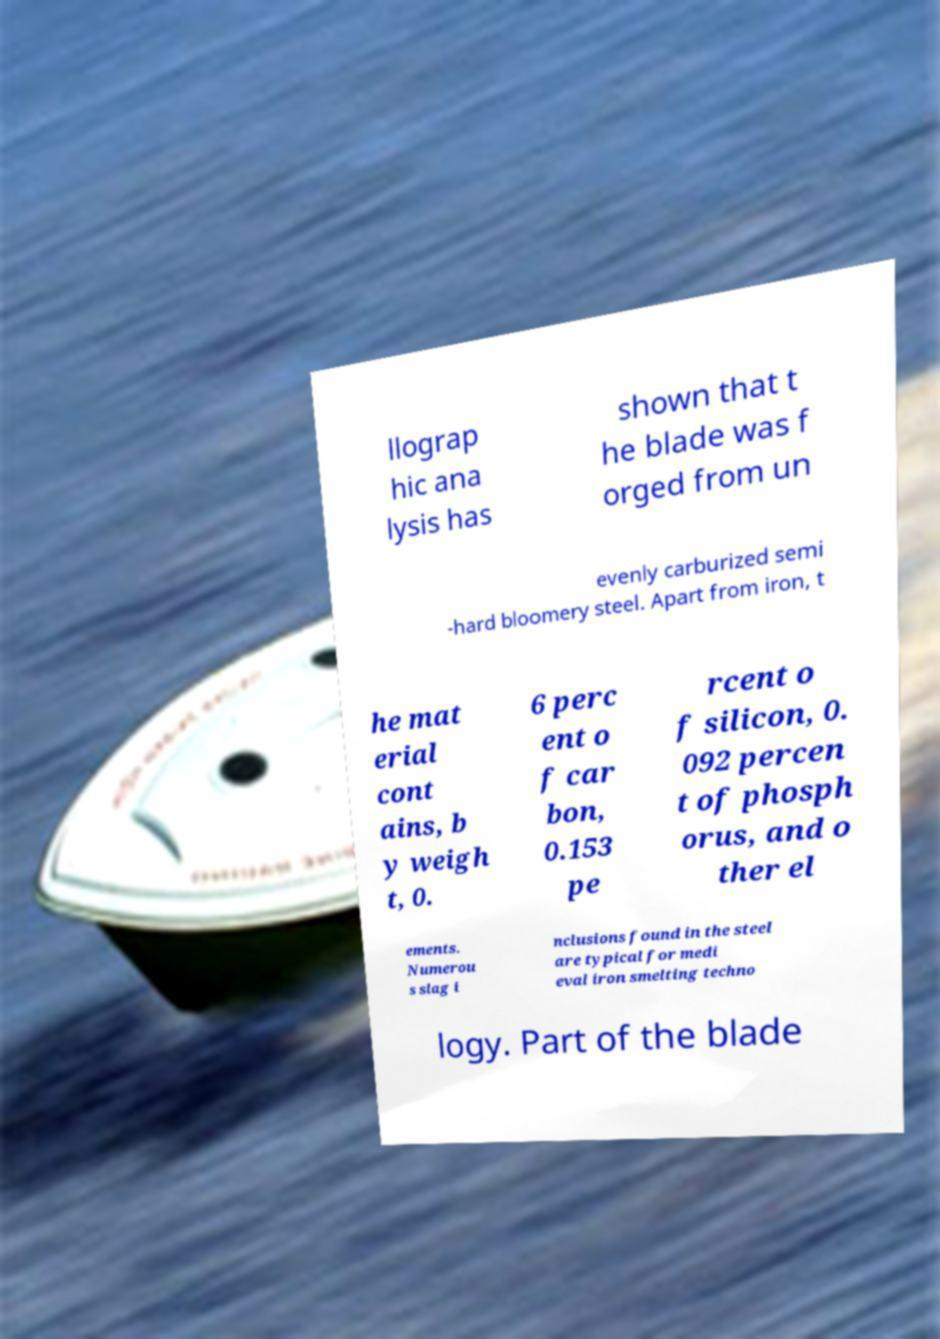What messages or text are displayed in this image? I need them in a readable, typed format. llograp hic ana lysis has shown that t he blade was f orged from un evenly carburized semi -hard bloomery steel. Apart from iron, t he mat erial cont ains, b y weigh t, 0. 6 perc ent o f car bon, 0.153 pe rcent o f silicon, 0. 092 percen t of phosph orus, and o ther el ements. Numerou s slag i nclusions found in the steel are typical for medi eval iron smelting techno logy. Part of the blade 